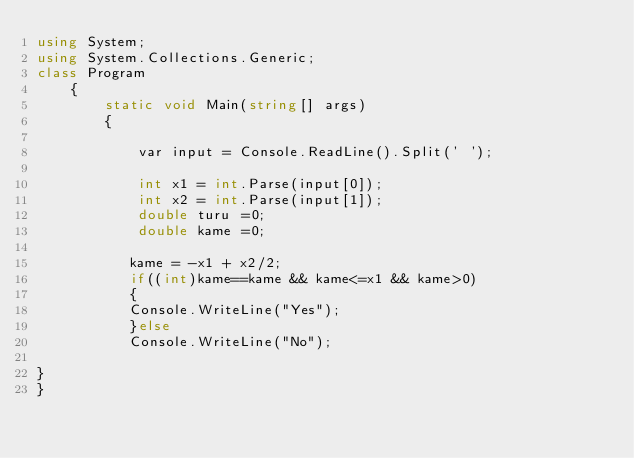Convert code to text. <code><loc_0><loc_0><loc_500><loc_500><_C#_>using System;
using System.Collections.Generic;
class Program
    {
        static void Main(string[] args)
        {

            var input = Console.ReadLine().Split(' ');

            int x1 = int.Parse(input[0]);
            int x2 = int.Parse(input[1]);
            double turu =0;
            double kame =0;

           kame = -x1 + x2/2;
           if((int)kame==kame && kame<=x1 && kame>0)
           {
           Console.WriteLine("Yes");
           }else
           Console.WriteLine("No");

}
}</code> 